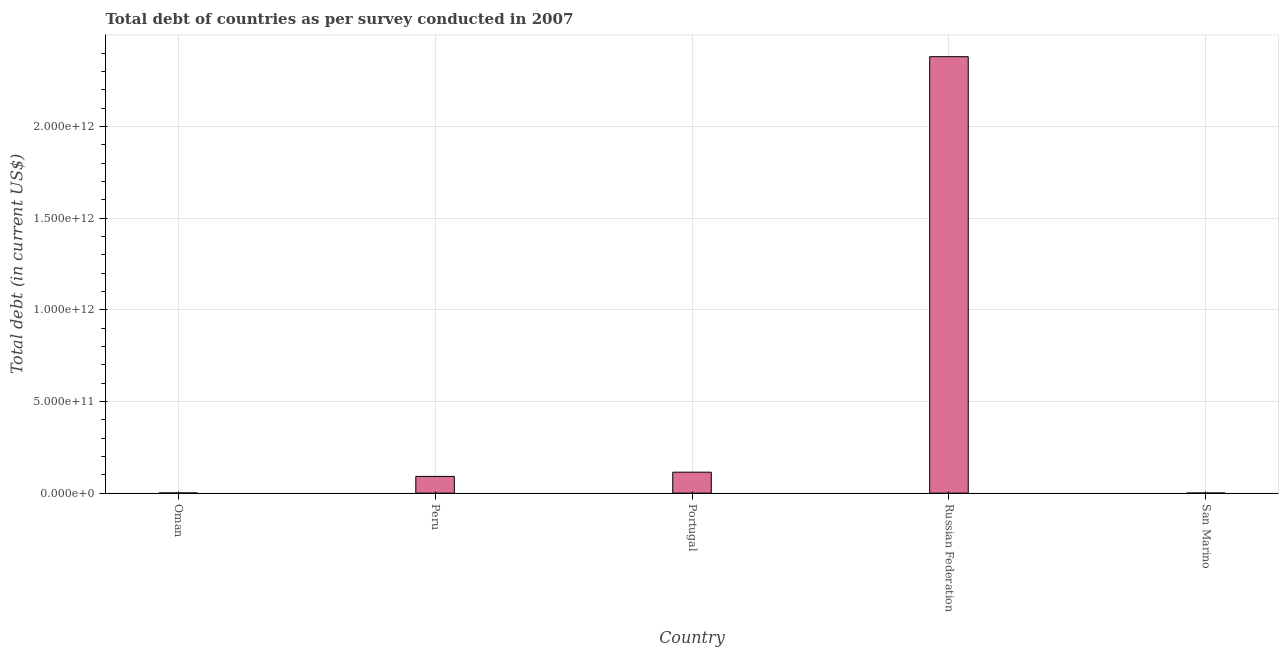Does the graph contain any zero values?
Make the answer very short. No. Does the graph contain grids?
Keep it short and to the point. Yes. What is the title of the graph?
Provide a short and direct response. Total debt of countries as per survey conducted in 2007. What is the label or title of the X-axis?
Provide a succinct answer. Country. What is the label or title of the Y-axis?
Offer a very short reply. Total debt (in current US$). What is the total debt in Peru?
Give a very brief answer. 9.12e+1. Across all countries, what is the maximum total debt?
Offer a very short reply. 2.38e+12. Across all countries, what is the minimum total debt?
Offer a terse response. 7.58e+08. In which country was the total debt maximum?
Offer a very short reply. Russian Federation. In which country was the total debt minimum?
Provide a short and direct response. San Marino. What is the sum of the total debt?
Your answer should be compact. 2.59e+12. What is the difference between the total debt in Russian Federation and San Marino?
Ensure brevity in your answer.  2.38e+12. What is the average total debt per country?
Ensure brevity in your answer.  5.17e+11. What is the median total debt?
Make the answer very short. 9.12e+1. In how many countries, is the total debt greater than 1400000000000 US$?
Offer a terse response. 1. What is the ratio of the total debt in Russian Federation to that in San Marino?
Provide a short and direct response. 3140.7. Is the total debt in Oman less than that in Russian Federation?
Your answer should be compact. Yes. What is the difference between the highest and the second highest total debt?
Give a very brief answer. 2.27e+12. Is the sum of the total debt in Oman and Portugal greater than the maximum total debt across all countries?
Provide a short and direct response. No. What is the difference between the highest and the lowest total debt?
Ensure brevity in your answer.  2.38e+12. In how many countries, is the total debt greater than the average total debt taken over all countries?
Offer a very short reply. 1. How many bars are there?
Offer a terse response. 5. Are all the bars in the graph horizontal?
Offer a very short reply. No. What is the difference between two consecutive major ticks on the Y-axis?
Provide a succinct answer. 5.00e+11. What is the Total debt (in current US$) in Oman?
Offer a very short reply. 1.00e+09. What is the Total debt (in current US$) of Peru?
Give a very brief answer. 9.12e+1. What is the Total debt (in current US$) in Portugal?
Offer a very short reply. 1.14e+11. What is the Total debt (in current US$) in Russian Federation?
Ensure brevity in your answer.  2.38e+12. What is the Total debt (in current US$) of San Marino?
Your response must be concise. 7.58e+08. What is the difference between the Total debt (in current US$) in Oman and Peru?
Give a very brief answer. -9.02e+1. What is the difference between the Total debt (in current US$) in Oman and Portugal?
Provide a short and direct response. -1.13e+11. What is the difference between the Total debt (in current US$) in Oman and Russian Federation?
Your answer should be very brief. -2.38e+12. What is the difference between the Total debt (in current US$) in Oman and San Marino?
Provide a succinct answer. 2.43e+08. What is the difference between the Total debt (in current US$) in Peru and Portugal?
Provide a succinct answer. -2.31e+1. What is the difference between the Total debt (in current US$) in Peru and Russian Federation?
Offer a very short reply. -2.29e+12. What is the difference between the Total debt (in current US$) in Peru and San Marino?
Provide a short and direct response. 9.04e+1. What is the difference between the Total debt (in current US$) in Portugal and Russian Federation?
Offer a terse response. -2.27e+12. What is the difference between the Total debt (in current US$) in Portugal and San Marino?
Offer a terse response. 1.14e+11. What is the difference between the Total debt (in current US$) in Russian Federation and San Marino?
Provide a short and direct response. 2.38e+12. What is the ratio of the Total debt (in current US$) in Oman to that in Peru?
Offer a terse response. 0.01. What is the ratio of the Total debt (in current US$) in Oman to that in Portugal?
Provide a succinct answer. 0.01. What is the ratio of the Total debt (in current US$) in Oman to that in Russian Federation?
Make the answer very short. 0. What is the ratio of the Total debt (in current US$) in Oman to that in San Marino?
Your response must be concise. 1.32. What is the ratio of the Total debt (in current US$) in Peru to that in Portugal?
Make the answer very short. 0.8. What is the ratio of the Total debt (in current US$) in Peru to that in Russian Federation?
Offer a terse response. 0.04. What is the ratio of the Total debt (in current US$) in Peru to that in San Marino?
Make the answer very short. 120.36. What is the ratio of the Total debt (in current US$) in Portugal to that in Russian Federation?
Provide a short and direct response. 0.05. What is the ratio of the Total debt (in current US$) in Portugal to that in San Marino?
Give a very brief answer. 150.84. What is the ratio of the Total debt (in current US$) in Russian Federation to that in San Marino?
Provide a succinct answer. 3140.7. 